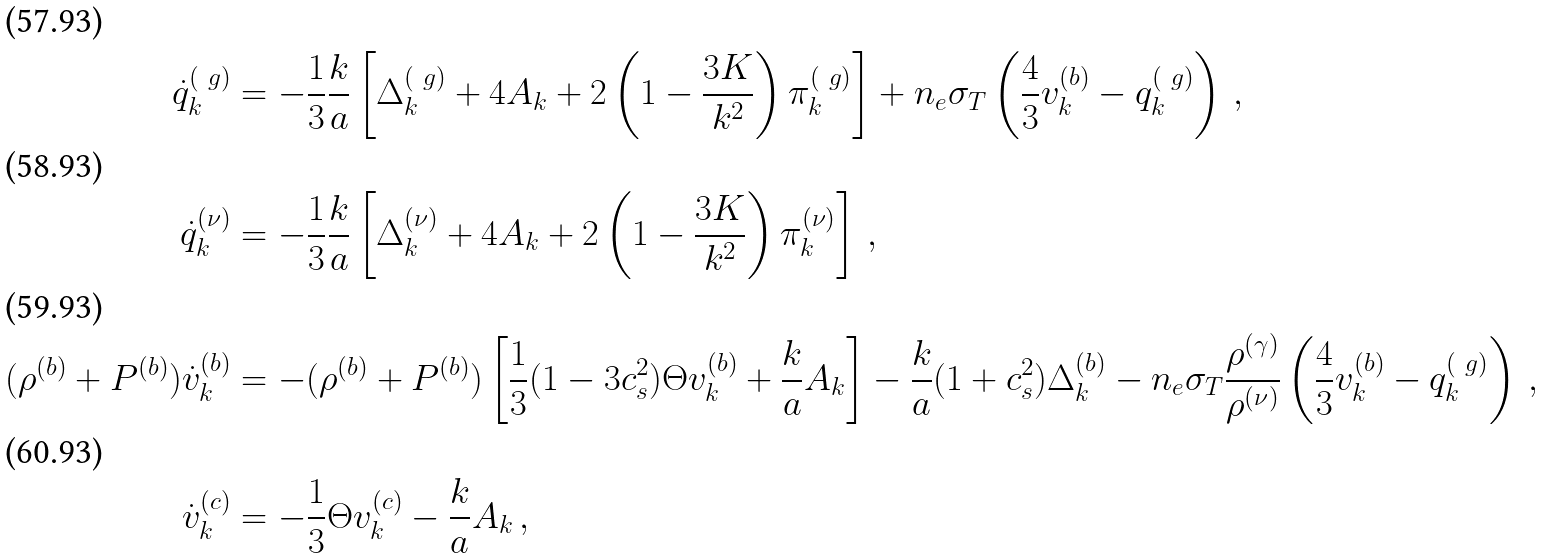Convert formula to latex. <formula><loc_0><loc_0><loc_500><loc_500>\dot { q } ^ { ( \ g ) } _ { k } & = - \frac { 1 } { 3 } \frac { k } { a } \left [ \Delta ^ { ( \ g ) } _ { k } + 4 A _ { k } + 2 \left ( 1 - \frac { 3 K } { k ^ { 2 } } \right ) \pi ^ { ( \ g ) } _ { k } \right ] + n _ { e } \sigma _ { T } \left ( \frac { 4 } { 3 } v ^ { ( b ) } _ { k } - q ^ { ( \ g ) } _ { k } \right ) \, , \\ \dot { q } ^ { ( \nu ) } _ { k } & = - \frac { 1 } { 3 } \frac { k } { a } \left [ \Delta ^ { ( \nu ) } _ { k } + 4 A _ { k } + 2 \left ( 1 - \frac { 3 K } { k ^ { 2 } } \right ) \pi ^ { ( \nu ) } _ { k } \right ] \, , \\ ( \rho ^ { ( b ) } + P ^ { ( b ) } ) \dot { v } ^ { ( b ) } _ { k } & = - ( \rho ^ { ( b ) } + P ^ { ( b ) } ) \left [ \frac { 1 } { 3 } ( 1 - 3 c _ { s } ^ { 2 } ) \Theta v ^ { ( b ) } _ { k } + \frac { k } { a } A _ { k } \right ] - \frac { k } { a } ( 1 + c _ { s } ^ { 2 } ) \Delta ^ { ( b ) } _ { k } - n _ { e } \sigma _ { T } \frac { \rho ^ { ( \gamma ) } } { \rho ^ { ( \nu ) } } \left ( \frac { 4 } { 3 } v ^ { ( b ) } _ { k } - q ^ { ( \ g ) } _ { k } \right ) \, , \\ \dot { v } ^ { ( c ) } _ { k } & = - \frac { 1 } { 3 } \Theta v ^ { ( c ) } _ { k } - \frac { k } { a } A _ { k } \, ,</formula> 